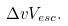<formula> <loc_0><loc_0><loc_500><loc_500>\Delta v V _ { e s c } .</formula> 